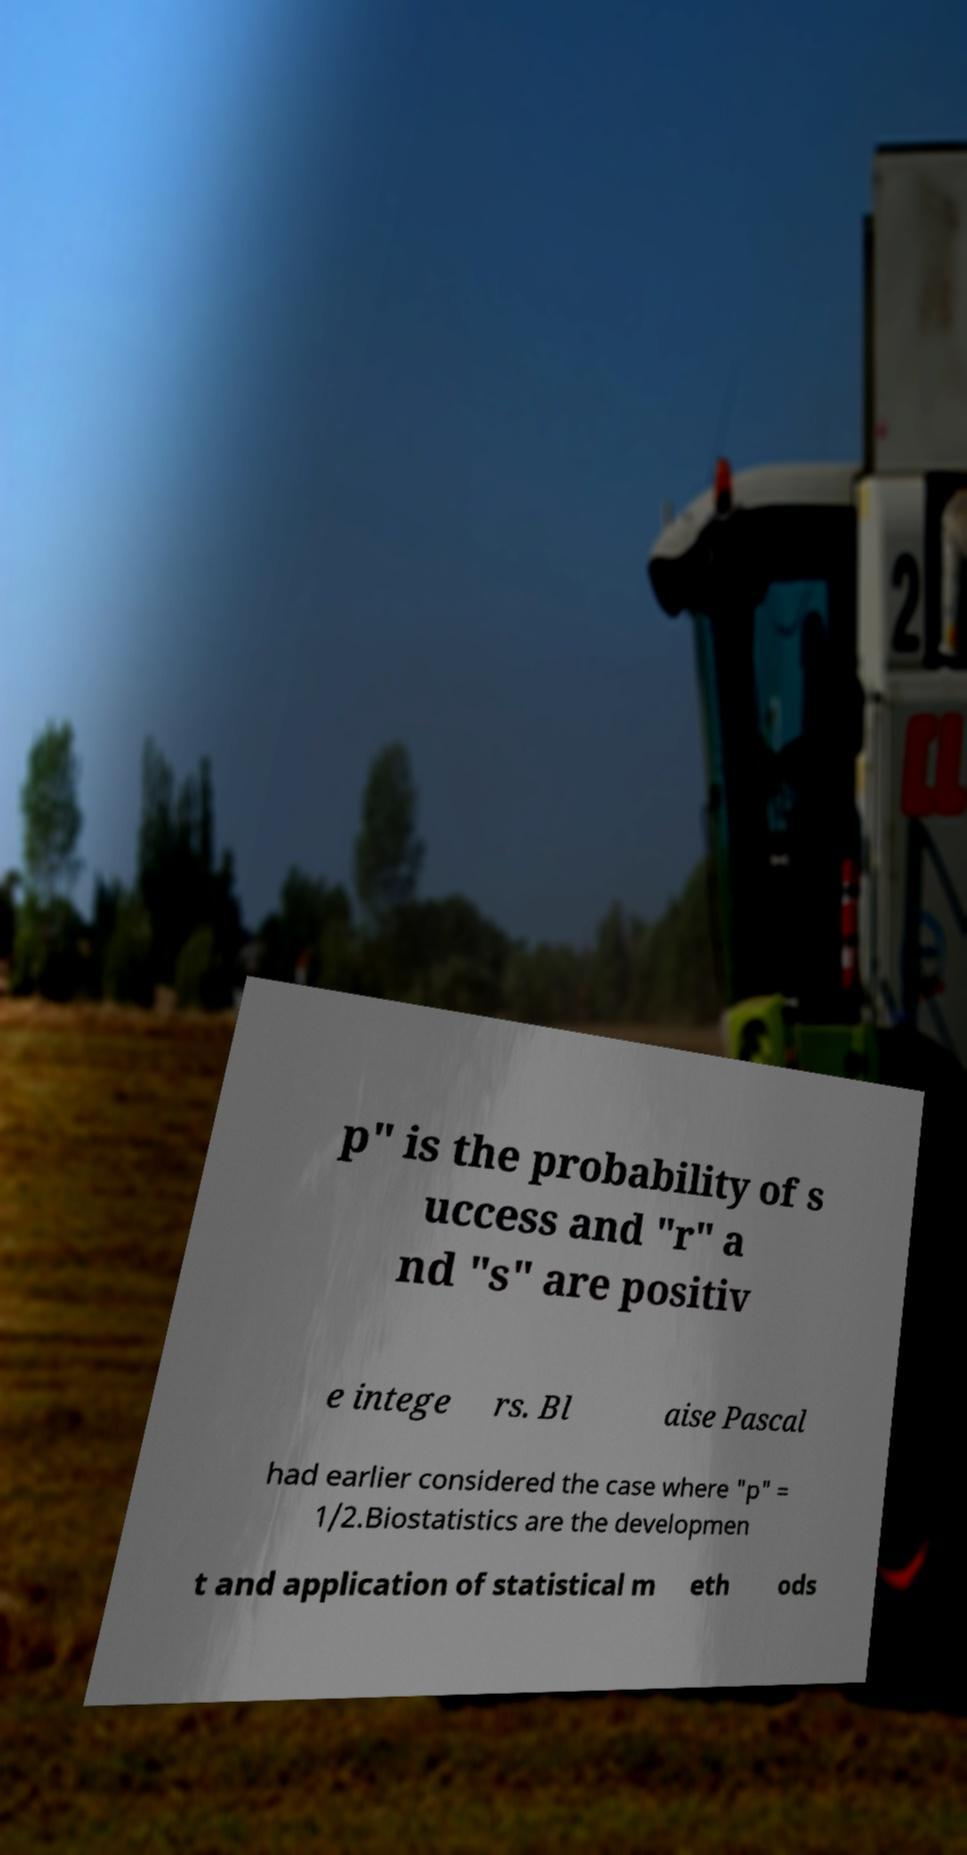Can you read and provide the text displayed in the image?This photo seems to have some interesting text. Can you extract and type it out for me? p" is the probability of s uccess and "r" a nd "s" are positiv e intege rs. Bl aise Pascal had earlier considered the case where "p" = 1/2.Biostatistics are the developmen t and application of statistical m eth ods 